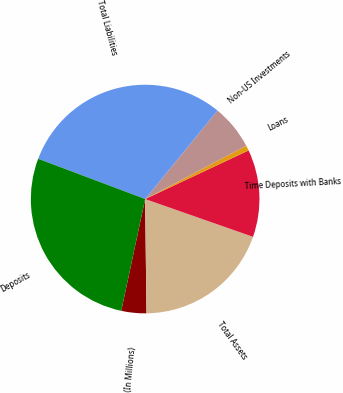<chart> <loc_0><loc_0><loc_500><loc_500><pie_chart><fcel>(In Millions)<fcel>Total Assets<fcel>Time Deposits with Banks<fcel>Loans<fcel>Non-US Investments<fcel>Total Liabilities<fcel>Deposits<nl><fcel>3.54%<fcel>19.45%<fcel>12.36%<fcel>0.73%<fcel>6.36%<fcel>30.19%<fcel>27.38%<nl></chart> 